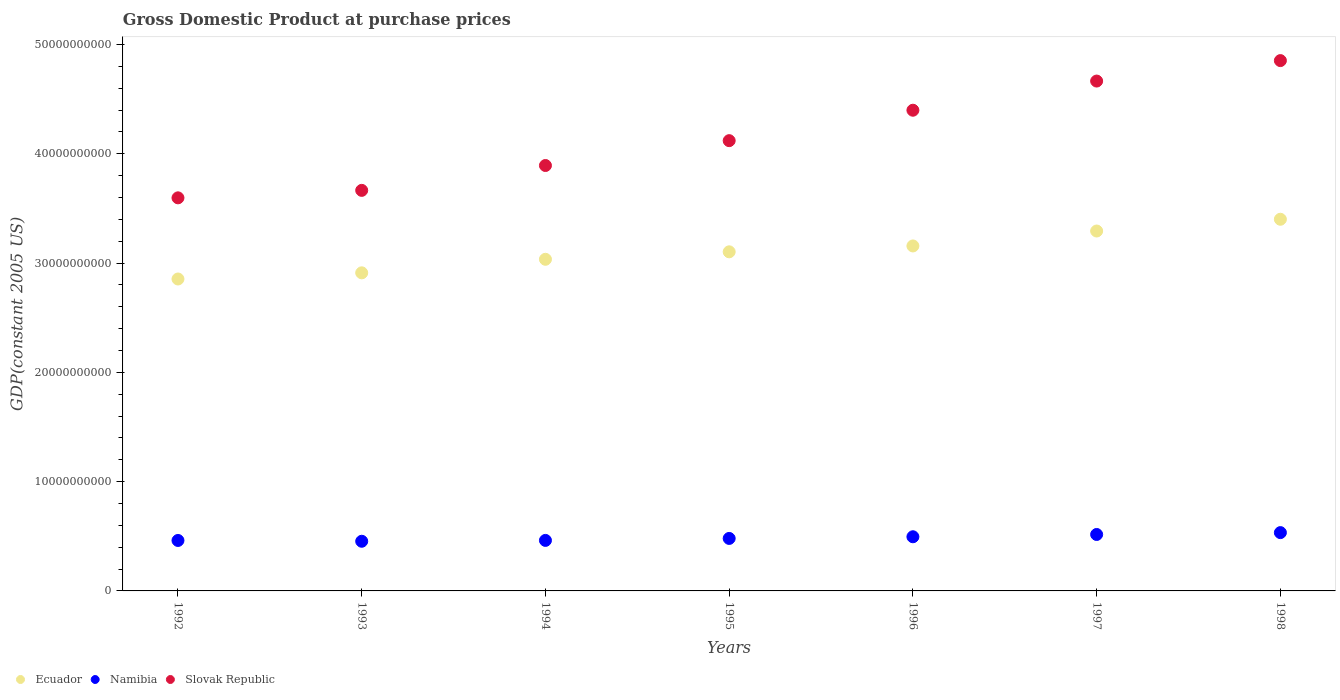How many different coloured dotlines are there?
Give a very brief answer. 3. Is the number of dotlines equal to the number of legend labels?
Provide a succinct answer. Yes. What is the GDP at purchase prices in Ecuador in 1994?
Ensure brevity in your answer.  3.03e+1. Across all years, what is the maximum GDP at purchase prices in Ecuador?
Keep it short and to the point. 3.40e+1. Across all years, what is the minimum GDP at purchase prices in Ecuador?
Offer a terse response. 2.85e+1. What is the total GDP at purchase prices in Slovak Republic in the graph?
Provide a short and direct response. 2.92e+11. What is the difference between the GDP at purchase prices in Ecuador in 1996 and that in 1997?
Ensure brevity in your answer.  -1.37e+09. What is the difference between the GDP at purchase prices in Namibia in 1992 and the GDP at purchase prices in Slovak Republic in 1996?
Your answer should be compact. -3.94e+1. What is the average GDP at purchase prices in Slovak Republic per year?
Keep it short and to the point. 4.17e+1. In the year 1997, what is the difference between the GDP at purchase prices in Namibia and GDP at purchase prices in Slovak Republic?
Keep it short and to the point. -4.15e+1. What is the ratio of the GDP at purchase prices in Slovak Republic in 1992 to that in 1994?
Make the answer very short. 0.92. Is the GDP at purchase prices in Slovak Republic in 1995 less than that in 1996?
Give a very brief answer. Yes. Is the difference between the GDP at purchase prices in Namibia in 1992 and 1997 greater than the difference between the GDP at purchase prices in Slovak Republic in 1992 and 1997?
Your answer should be very brief. Yes. What is the difference between the highest and the second highest GDP at purchase prices in Ecuador?
Provide a succinct answer. 1.08e+09. What is the difference between the highest and the lowest GDP at purchase prices in Slovak Republic?
Keep it short and to the point. 1.26e+1. Is the sum of the GDP at purchase prices in Ecuador in 1992 and 1994 greater than the maximum GDP at purchase prices in Slovak Republic across all years?
Ensure brevity in your answer.  Yes. Is it the case that in every year, the sum of the GDP at purchase prices in Slovak Republic and GDP at purchase prices in Namibia  is greater than the GDP at purchase prices in Ecuador?
Offer a very short reply. Yes. Is the GDP at purchase prices in Slovak Republic strictly greater than the GDP at purchase prices in Namibia over the years?
Your response must be concise. Yes. Are the values on the major ticks of Y-axis written in scientific E-notation?
Offer a very short reply. No. Does the graph contain grids?
Offer a terse response. No. How many legend labels are there?
Give a very brief answer. 3. What is the title of the graph?
Your response must be concise. Gross Domestic Product at purchase prices. What is the label or title of the X-axis?
Your answer should be very brief. Years. What is the label or title of the Y-axis?
Your answer should be very brief. GDP(constant 2005 US). What is the GDP(constant 2005 US) in Ecuador in 1992?
Offer a very short reply. 2.85e+1. What is the GDP(constant 2005 US) of Namibia in 1992?
Provide a succinct answer. 4.62e+09. What is the GDP(constant 2005 US) of Slovak Republic in 1992?
Give a very brief answer. 3.60e+1. What is the GDP(constant 2005 US) of Ecuador in 1993?
Offer a very short reply. 2.91e+1. What is the GDP(constant 2005 US) of Namibia in 1993?
Your response must be concise. 4.54e+09. What is the GDP(constant 2005 US) of Slovak Republic in 1993?
Your response must be concise. 3.67e+1. What is the GDP(constant 2005 US) in Ecuador in 1994?
Provide a short and direct response. 3.03e+1. What is the GDP(constant 2005 US) of Namibia in 1994?
Offer a very short reply. 4.62e+09. What is the GDP(constant 2005 US) in Slovak Republic in 1994?
Offer a terse response. 3.89e+1. What is the GDP(constant 2005 US) of Ecuador in 1995?
Ensure brevity in your answer.  3.10e+1. What is the GDP(constant 2005 US) in Namibia in 1995?
Your answer should be very brief. 4.80e+09. What is the GDP(constant 2005 US) of Slovak Republic in 1995?
Provide a short and direct response. 4.12e+1. What is the GDP(constant 2005 US) in Ecuador in 1996?
Keep it short and to the point. 3.16e+1. What is the GDP(constant 2005 US) in Namibia in 1996?
Provide a short and direct response. 4.96e+09. What is the GDP(constant 2005 US) of Slovak Republic in 1996?
Your response must be concise. 4.40e+1. What is the GDP(constant 2005 US) in Ecuador in 1997?
Your response must be concise. 3.29e+1. What is the GDP(constant 2005 US) in Namibia in 1997?
Your answer should be very brief. 5.17e+09. What is the GDP(constant 2005 US) of Slovak Republic in 1997?
Provide a succinct answer. 4.67e+1. What is the GDP(constant 2005 US) in Ecuador in 1998?
Your answer should be very brief. 3.40e+1. What is the GDP(constant 2005 US) in Namibia in 1998?
Your response must be concise. 5.34e+09. What is the GDP(constant 2005 US) of Slovak Republic in 1998?
Your response must be concise. 4.85e+1. Across all years, what is the maximum GDP(constant 2005 US) in Ecuador?
Give a very brief answer. 3.40e+1. Across all years, what is the maximum GDP(constant 2005 US) in Namibia?
Give a very brief answer. 5.34e+09. Across all years, what is the maximum GDP(constant 2005 US) in Slovak Republic?
Your answer should be compact. 4.85e+1. Across all years, what is the minimum GDP(constant 2005 US) in Ecuador?
Your response must be concise. 2.85e+1. Across all years, what is the minimum GDP(constant 2005 US) in Namibia?
Provide a short and direct response. 4.54e+09. Across all years, what is the minimum GDP(constant 2005 US) in Slovak Republic?
Ensure brevity in your answer.  3.60e+1. What is the total GDP(constant 2005 US) of Ecuador in the graph?
Make the answer very short. 2.18e+11. What is the total GDP(constant 2005 US) of Namibia in the graph?
Your response must be concise. 3.40e+1. What is the total GDP(constant 2005 US) in Slovak Republic in the graph?
Make the answer very short. 2.92e+11. What is the difference between the GDP(constant 2005 US) of Ecuador in 1992 and that in 1993?
Make the answer very short. -5.63e+08. What is the difference between the GDP(constant 2005 US) in Namibia in 1992 and that in 1993?
Offer a very short reply. 7.29e+07. What is the difference between the GDP(constant 2005 US) of Slovak Republic in 1992 and that in 1993?
Provide a short and direct response. -6.84e+08. What is the difference between the GDP(constant 2005 US) of Ecuador in 1992 and that in 1994?
Give a very brief answer. -1.80e+09. What is the difference between the GDP(constant 2005 US) in Namibia in 1992 and that in 1994?
Provide a succinct answer. -5.68e+06. What is the difference between the GDP(constant 2005 US) in Slovak Republic in 1992 and that in 1994?
Your answer should be compact. -2.96e+09. What is the difference between the GDP(constant 2005 US) in Ecuador in 1992 and that in 1995?
Ensure brevity in your answer.  -2.49e+09. What is the difference between the GDP(constant 2005 US) of Namibia in 1992 and that in 1995?
Make the answer very short. -1.86e+08. What is the difference between the GDP(constant 2005 US) in Slovak Republic in 1992 and that in 1995?
Give a very brief answer. -5.23e+09. What is the difference between the GDP(constant 2005 US) of Ecuador in 1992 and that in 1996?
Provide a succinct answer. -3.02e+09. What is the difference between the GDP(constant 2005 US) of Namibia in 1992 and that in 1996?
Provide a succinct answer. -3.39e+08. What is the difference between the GDP(constant 2005 US) of Slovak Republic in 1992 and that in 1996?
Offer a terse response. -8.02e+09. What is the difference between the GDP(constant 2005 US) in Ecuador in 1992 and that in 1997?
Provide a succinct answer. -4.39e+09. What is the difference between the GDP(constant 2005 US) in Namibia in 1992 and that in 1997?
Give a very brief answer. -5.48e+08. What is the difference between the GDP(constant 2005 US) in Slovak Republic in 1992 and that in 1997?
Provide a short and direct response. -1.07e+1. What is the difference between the GDP(constant 2005 US) of Ecuador in 1992 and that in 1998?
Your answer should be compact. -5.47e+09. What is the difference between the GDP(constant 2005 US) of Namibia in 1992 and that in 1998?
Your answer should be very brief. -7.18e+08. What is the difference between the GDP(constant 2005 US) of Slovak Republic in 1992 and that in 1998?
Ensure brevity in your answer.  -1.26e+1. What is the difference between the GDP(constant 2005 US) of Ecuador in 1993 and that in 1994?
Your answer should be compact. -1.24e+09. What is the difference between the GDP(constant 2005 US) in Namibia in 1993 and that in 1994?
Provide a short and direct response. -7.86e+07. What is the difference between the GDP(constant 2005 US) in Slovak Republic in 1993 and that in 1994?
Provide a succinct answer. -2.27e+09. What is the difference between the GDP(constant 2005 US) of Ecuador in 1993 and that in 1995?
Give a very brief answer. -1.92e+09. What is the difference between the GDP(constant 2005 US) of Namibia in 1993 and that in 1995?
Your answer should be very brief. -2.59e+08. What is the difference between the GDP(constant 2005 US) of Slovak Republic in 1993 and that in 1995?
Your answer should be compact. -4.55e+09. What is the difference between the GDP(constant 2005 US) of Ecuador in 1993 and that in 1996?
Your response must be concise. -2.46e+09. What is the difference between the GDP(constant 2005 US) of Namibia in 1993 and that in 1996?
Provide a succinct answer. -4.12e+08. What is the difference between the GDP(constant 2005 US) in Slovak Republic in 1993 and that in 1996?
Offer a terse response. -7.33e+09. What is the difference between the GDP(constant 2005 US) of Ecuador in 1993 and that in 1997?
Keep it short and to the point. -3.83e+09. What is the difference between the GDP(constant 2005 US) of Namibia in 1993 and that in 1997?
Offer a terse response. -6.21e+08. What is the difference between the GDP(constant 2005 US) of Slovak Republic in 1993 and that in 1997?
Your response must be concise. -1.00e+1. What is the difference between the GDP(constant 2005 US) in Ecuador in 1993 and that in 1998?
Offer a terse response. -4.90e+09. What is the difference between the GDP(constant 2005 US) in Namibia in 1993 and that in 1998?
Offer a terse response. -7.91e+08. What is the difference between the GDP(constant 2005 US) in Slovak Republic in 1993 and that in 1998?
Provide a succinct answer. -1.19e+1. What is the difference between the GDP(constant 2005 US) of Ecuador in 1994 and that in 1995?
Ensure brevity in your answer.  -6.84e+08. What is the difference between the GDP(constant 2005 US) in Namibia in 1994 and that in 1995?
Your answer should be compact. -1.80e+08. What is the difference between the GDP(constant 2005 US) in Slovak Republic in 1994 and that in 1995?
Keep it short and to the point. -2.27e+09. What is the difference between the GDP(constant 2005 US) in Ecuador in 1994 and that in 1996?
Offer a very short reply. -1.22e+09. What is the difference between the GDP(constant 2005 US) in Namibia in 1994 and that in 1996?
Offer a terse response. -3.34e+08. What is the difference between the GDP(constant 2005 US) of Slovak Republic in 1994 and that in 1996?
Ensure brevity in your answer.  -5.06e+09. What is the difference between the GDP(constant 2005 US) of Ecuador in 1994 and that in 1997?
Provide a short and direct response. -2.59e+09. What is the difference between the GDP(constant 2005 US) in Namibia in 1994 and that in 1997?
Offer a terse response. -5.43e+08. What is the difference between the GDP(constant 2005 US) of Slovak Republic in 1994 and that in 1997?
Offer a terse response. -7.73e+09. What is the difference between the GDP(constant 2005 US) in Ecuador in 1994 and that in 1998?
Give a very brief answer. -3.66e+09. What is the difference between the GDP(constant 2005 US) of Namibia in 1994 and that in 1998?
Your answer should be compact. -7.13e+08. What is the difference between the GDP(constant 2005 US) of Slovak Republic in 1994 and that in 1998?
Keep it short and to the point. -9.60e+09. What is the difference between the GDP(constant 2005 US) of Ecuador in 1995 and that in 1996?
Provide a succinct answer. -5.37e+08. What is the difference between the GDP(constant 2005 US) of Namibia in 1995 and that in 1996?
Offer a very short reply. -1.53e+08. What is the difference between the GDP(constant 2005 US) in Slovak Republic in 1995 and that in 1996?
Provide a succinct answer. -2.78e+09. What is the difference between the GDP(constant 2005 US) in Ecuador in 1995 and that in 1997?
Your response must be concise. -1.90e+09. What is the difference between the GDP(constant 2005 US) of Namibia in 1995 and that in 1997?
Keep it short and to the point. -3.62e+08. What is the difference between the GDP(constant 2005 US) of Slovak Republic in 1995 and that in 1997?
Provide a succinct answer. -5.45e+09. What is the difference between the GDP(constant 2005 US) of Ecuador in 1995 and that in 1998?
Offer a very short reply. -2.98e+09. What is the difference between the GDP(constant 2005 US) in Namibia in 1995 and that in 1998?
Ensure brevity in your answer.  -5.32e+08. What is the difference between the GDP(constant 2005 US) in Slovak Republic in 1995 and that in 1998?
Your answer should be compact. -7.33e+09. What is the difference between the GDP(constant 2005 US) of Ecuador in 1996 and that in 1997?
Provide a succinct answer. -1.37e+09. What is the difference between the GDP(constant 2005 US) in Namibia in 1996 and that in 1997?
Your answer should be compact. -2.09e+08. What is the difference between the GDP(constant 2005 US) of Slovak Republic in 1996 and that in 1997?
Make the answer very short. -2.67e+09. What is the difference between the GDP(constant 2005 US) in Ecuador in 1996 and that in 1998?
Offer a very short reply. -2.44e+09. What is the difference between the GDP(constant 2005 US) in Namibia in 1996 and that in 1998?
Offer a terse response. -3.79e+08. What is the difference between the GDP(constant 2005 US) of Slovak Republic in 1996 and that in 1998?
Offer a terse response. -4.54e+09. What is the difference between the GDP(constant 2005 US) of Ecuador in 1997 and that in 1998?
Provide a short and direct response. -1.08e+09. What is the difference between the GDP(constant 2005 US) of Namibia in 1997 and that in 1998?
Provide a succinct answer. -1.70e+08. What is the difference between the GDP(constant 2005 US) of Slovak Republic in 1997 and that in 1998?
Make the answer very short. -1.87e+09. What is the difference between the GDP(constant 2005 US) of Ecuador in 1992 and the GDP(constant 2005 US) of Namibia in 1993?
Make the answer very short. 2.40e+1. What is the difference between the GDP(constant 2005 US) of Ecuador in 1992 and the GDP(constant 2005 US) of Slovak Republic in 1993?
Your answer should be very brief. -8.11e+09. What is the difference between the GDP(constant 2005 US) in Namibia in 1992 and the GDP(constant 2005 US) in Slovak Republic in 1993?
Your answer should be very brief. -3.20e+1. What is the difference between the GDP(constant 2005 US) in Ecuador in 1992 and the GDP(constant 2005 US) in Namibia in 1994?
Your answer should be compact. 2.39e+1. What is the difference between the GDP(constant 2005 US) of Ecuador in 1992 and the GDP(constant 2005 US) of Slovak Republic in 1994?
Your response must be concise. -1.04e+1. What is the difference between the GDP(constant 2005 US) in Namibia in 1992 and the GDP(constant 2005 US) in Slovak Republic in 1994?
Offer a very short reply. -3.43e+1. What is the difference between the GDP(constant 2005 US) in Ecuador in 1992 and the GDP(constant 2005 US) in Namibia in 1995?
Ensure brevity in your answer.  2.37e+1. What is the difference between the GDP(constant 2005 US) in Ecuador in 1992 and the GDP(constant 2005 US) in Slovak Republic in 1995?
Provide a succinct answer. -1.27e+1. What is the difference between the GDP(constant 2005 US) of Namibia in 1992 and the GDP(constant 2005 US) of Slovak Republic in 1995?
Offer a terse response. -3.66e+1. What is the difference between the GDP(constant 2005 US) in Ecuador in 1992 and the GDP(constant 2005 US) in Namibia in 1996?
Provide a succinct answer. 2.36e+1. What is the difference between the GDP(constant 2005 US) of Ecuador in 1992 and the GDP(constant 2005 US) of Slovak Republic in 1996?
Ensure brevity in your answer.  -1.54e+1. What is the difference between the GDP(constant 2005 US) in Namibia in 1992 and the GDP(constant 2005 US) in Slovak Republic in 1996?
Provide a short and direct response. -3.94e+1. What is the difference between the GDP(constant 2005 US) of Ecuador in 1992 and the GDP(constant 2005 US) of Namibia in 1997?
Your response must be concise. 2.34e+1. What is the difference between the GDP(constant 2005 US) in Ecuador in 1992 and the GDP(constant 2005 US) in Slovak Republic in 1997?
Provide a succinct answer. -1.81e+1. What is the difference between the GDP(constant 2005 US) in Namibia in 1992 and the GDP(constant 2005 US) in Slovak Republic in 1997?
Your answer should be very brief. -4.20e+1. What is the difference between the GDP(constant 2005 US) in Ecuador in 1992 and the GDP(constant 2005 US) in Namibia in 1998?
Your answer should be compact. 2.32e+1. What is the difference between the GDP(constant 2005 US) in Ecuador in 1992 and the GDP(constant 2005 US) in Slovak Republic in 1998?
Provide a short and direct response. -2.00e+1. What is the difference between the GDP(constant 2005 US) in Namibia in 1992 and the GDP(constant 2005 US) in Slovak Republic in 1998?
Provide a succinct answer. -4.39e+1. What is the difference between the GDP(constant 2005 US) of Ecuador in 1993 and the GDP(constant 2005 US) of Namibia in 1994?
Offer a terse response. 2.45e+1. What is the difference between the GDP(constant 2005 US) in Ecuador in 1993 and the GDP(constant 2005 US) in Slovak Republic in 1994?
Offer a terse response. -9.82e+09. What is the difference between the GDP(constant 2005 US) of Namibia in 1993 and the GDP(constant 2005 US) of Slovak Republic in 1994?
Give a very brief answer. -3.44e+1. What is the difference between the GDP(constant 2005 US) in Ecuador in 1993 and the GDP(constant 2005 US) in Namibia in 1995?
Offer a terse response. 2.43e+1. What is the difference between the GDP(constant 2005 US) of Ecuador in 1993 and the GDP(constant 2005 US) of Slovak Republic in 1995?
Your response must be concise. -1.21e+1. What is the difference between the GDP(constant 2005 US) of Namibia in 1993 and the GDP(constant 2005 US) of Slovak Republic in 1995?
Give a very brief answer. -3.67e+1. What is the difference between the GDP(constant 2005 US) in Ecuador in 1993 and the GDP(constant 2005 US) in Namibia in 1996?
Offer a very short reply. 2.42e+1. What is the difference between the GDP(constant 2005 US) of Ecuador in 1993 and the GDP(constant 2005 US) of Slovak Republic in 1996?
Your answer should be compact. -1.49e+1. What is the difference between the GDP(constant 2005 US) in Namibia in 1993 and the GDP(constant 2005 US) in Slovak Republic in 1996?
Make the answer very short. -3.94e+1. What is the difference between the GDP(constant 2005 US) of Ecuador in 1993 and the GDP(constant 2005 US) of Namibia in 1997?
Give a very brief answer. 2.39e+1. What is the difference between the GDP(constant 2005 US) in Ecuador in 1993 and the GDP(constant 2005 US) in Slovak Republic in 1997?
Ensure brevity in your answer.  -1.75e+1. What is the difference between the GDP(constant 2005 US) in Namibia in 1993 and the GDP(constant 2005 US) in Slovak Republic in 1997?
Your answer should be very brief. -4.21e+1. What is the difference between the GDP(constant 2005 US) of Ecuador in 1993 and the GDP(constant 2005 US) of Namibia in 1998?
Offer a terse response. 2.38e+1. What is the difference between the GDP(constant 2005 US) of Ecuador in 1993 and the GDP(constant 2005 US) of Slovak Republic in 1998?
Give a very brief answer. -1.94e+1. What is the difference between the GDP(constant 2005 US) of Namibia in 1993 and the GDP(constant 2005 US) of Slovak Republic in 1998?
Offer a very short reply. -4.40e+1. What is the difference between the GDP(constant 2005 US) in Ecuador in 1994 and the GDP(constant 2005 US) in Namibia in 1995?
Keep it short and to the point. 2.55e+1. What is the difference between the GDP(constant 2005 US) of Ecuador in 1994 and the GDP(constant 2005 US) of Slovak Republic in 1995?
Offer a terse response. -1.09e+1. What is the difference between the GDP(constant 2005 US) in Namibia in 1994 and the GDP(constant 2005 US) in Slovak Republic in 1995?
Provide a short and direct response. -3.66e+1. What is the difference between the GDP(constant 2005 US) of Ecuador in 1994 and the GDP(constant 2005 US) of Namibia in 1996?
Keep it short and to the point. 2.54e+1. What is the difference between the GDP(constant 2005 US) of Ecuador in 1994 and the GDP(constant 2005 US) of Slovak Republic in 1996?
Give a very brief answer. -1.36e+1. What is the difference between the GDP(constant 2005 US) in Namibia in 1994 and the GDP(constant 2005 US) in Slovak Republic in 1996?
Give a very brief answer. -3.94e+1. What is the difference between the GDP(constant 2005 US) of Ecuador in 1994 and the GDP(constant 2005 US) of Namibia in 1997?
Your response must be concise. 2.52e+1. What is the difference between the GDP(constant 2005 US) in Ecuador in 1994 and the GDP(constant 2005 US) in Slovak Republic in 1997?
Provide a short and direct response. -1.63e+1. What is the difference between the GDP(constant 2005 US) of Namibia in 1994 and the GDP(constant 2005 US) of Slovak Republic in 1997?
Your answer should be compact. -4.20e+1. What is the difference between the GDP(constant 2005 US) of Ecuador in 1994 and the GDP(constant 2005 US) of Namibia in 1998?
Ensure brevity in your answer.  2.50e+1. What is the difference between the GDP(constant 2005 US) of Ecuador in 1994 and the GDP(constant 2005 US) of Slovak Republic in 1998?
Make the answer very short. -1.82e+1. What is the difference between the GDP(constant 2005 US) in Namibia in 1994 and the GDP(constant 2005 US) in Slovak Republic in 1998?
Provide a short and direct response. -4.39e+1. What is the difference between the GDP(constant 2005 US) of Ecuador in 1995 and the GDP(constant 2005 US) of Namibia in 1996?
Ensure brevity in your answer.  2.61e+1. What is the difference between the GDP(constant 2005 US) of Ecuador in 1995 and the GDP(constant 2005 US) of Slovak Republic in 1996?
Your answer should be compact. -1.30e+1. What is the difference between the GDP(constant 2005 US) of Namibia in 1995 and the GDP(constant 2005 US) of Slovak Republic in 1996?
Make the answer very short. -3.92e+1. What is the difference between the GDP(constant 2005 US) in Ecuador in 1995 and the GDP(constant 2005 US) in Namibia in 1997?
Your response must be concise. 2.59e+1. What is the difference between the GDP(constant 2005 US) of Ecuador in 1995 and the GDP(constant 2005 US) of Slovak Republic in 1997?
Ensure brevity in your answer.  -1.56e+1. What is the difference between the GDP(constant 2005 US) in Namibia in 1995 and the GDP(constant 2005 US) in Slovak Republic in 1997?
Make the answer very short. -4.19e+1. What is the difference between the GDP(constant 2005 US) in Ecuador in 1995 and the GDP(constant 2005 US) in Namibia in 1998?
Your response must be concise. 2.57e+1. What is the difference between the GDP(constant 2005 US) in Ecuador in 1995 and the GDP(constant 2005 US) in Slovak Republic in 1998?
Ensure brevity in your answer.  -1.75e+1. What is the difference between the GDP(constant 2005 US) in Namibia in 1995 and the GDP(constant 2005 US) in Slovak Republic in 1998?
Give a very brief answer. -4.37e+1. What is the difference between the GDP(constant 2005 US) in Ecuador in 1996 and the GDP(constant 2005 US) in Namibia in 1997?
Give a very brief answer. 2.64e+1. What is the difference between the GDP(constant 2005 US) of Ecuador in 1996 and the GDP(constant 2005 US) of Slovak Republic in 1997?
Provide a short and direct response. -1.51e+1. What is the difference between the GDP(constant 2005 US) of Namibia in 1996 and the GDP(constant 2005 US) of Slovak Republic in 1997?
Make the answer very short. -4.17e+1. What is the difference between the GDP(constant 2005 US) of Ecuador in 1996 and the GDP(constant 2005 US) of Namibia in 1998?
Ensure brevity in your answer.  2.62e+1. What is the difference between the GDP(constant 2005 US) in Ecuador in 1996 and the GDP(constant 2005 US) in Slovak Republic in 1998?
Offer a terse response. -1.70e+1. What is the difference between the GDP(constant 2005 US) in Namibia in 1996 and the GDP(constant 2005 US) in Slovak Republic in 1998?
Offer a very short reply. -4.36e+1. What is the difference between the GDP(constant 2005 US) of Ecuador in 1997 and the GDP(constant 2005 US) of Namibia in 1998?
Give a very brief answer. 2.76e+1. What is the difference between the GDP(constant 2005 US) in Ecuador in 1997 and the GDP(constant 2005 US) in Slovak Republic in 1998?
Give a very brief answer. -1.56e+1. What is the difference between the GDP(constant 2005 US) in Namibia in 1997 and the GDP(constant 2005 US) in Slovak Republic in 1998?
Your response must be concise. -4.34e+1. What is the average GDP(constant 2005 US) in Ecuador per year?
Ensure brevity in your answer.  3.11e+1. What is the average GDP(constant 2005 US) of Namibia per year?
Offer a very short reply. 4.86e+09. What is the average GDP(constant 2005 US) in Slovak Republic per year?
Offer a terse response. 4.17e+1. In the year 1992, what is the difference between the GDP(constant 2005 US) of Ecuador and GDP(constant 2005 US) of Namibia?
Offer a very short reply. 2.39e+1. In the year 1992, what is the difference between the GDP(constant 2005 US) in Ecuador and GDP(constant 2005 US) in Slovak Republic?
Provide a short and direct response. -7.43e+09. In the year 1992, what is the difference between the GDP(constant 2005 US) of Namibia and GDP(constant 2005 US) of Slovak Republic?
Make the answer very short. -3.14e+1. In the year 1993, what is the difference between the GDP(constant 2005 US) of Ecuador and GDP(constant 2005 US) of Namibia?
Your response must be concise. 2.46e+1. In the year 1993, what is the difference between the GDP(constant 2005 US) in Ecuador and GDP(constant 2005 US) in Slovak Republic?
Keep it short and to the point. -7.55e+09. In the year 1993, what is the difference between the GDP(constant 2005 US) of Namibia and GDP(constant 2005 US) of Slovak Republic?
Provide a succinct answer. -3.21e+1. In the year 1994, what is the difference between the GDP(constant 2005 US) in Ecuador and GDP(constant 2005 US) in Namibia?
Keep it short and to the point. 2.57e+1. In the year 1994, what is the difference between the GDP(constant 2005 US) of Ecuador and GDP(constant 2005 US) of Slovak Republic?
Ensure brevity in your answer.  -8.58e+09. In the year 1994, what is the difference between the GDP(constant 2005 US) of Namibia and GDP(constant 2005 US) of Slovak Republic?
Your response must be concise. -3.43e+1. In the year 1995, what is the difference between the GDP(constant 2005 US) of Ecuador and GDP(constant 2005 US) of Namibia?
Provide a short and direct response. 2.62e+1. In the year 1995, what is the difference between the GDP(constant 2005 US) of Ecuador and GDP(constant 2005 US) of Slovak Republic?
Your response must be concise. -1.02e+1. In the year 1995, what is the difference between the GDP(constant 2005 US) of Namibia and GDP(constant 2005 US) of Slovak Republic?
Offer a very short reply. -3.64e+1. In the year 1996, what is the difference between the GDP(constant 2005 US) in Ecuador and GDP(constant 2005 US) in Namibia?
Provide a succinct answer. 2.66e+1. In the year 1996, what is the difference between the GDP(constant 2005 US) in Ecuador and GDP(constant 2005 US) in Slovak Republic?
Your answer should be very brief. -1.24e+1. In the year 1996, what is the difference between the GDP(constant 2005 US) in Namibia and GDP(constant 2005 US) in Slovak Republic?
Provide a short and direct response. -3.90e+1. In the year 1997, what is the difference between the GDP(constant 2005 US) of Ecuador and GDP(constant 2005 US) of Namibia?
Your answer should be very brief. 2.78e+1. In the year 1997, what is the difference between the GDP(constant 2005 US) of Ecuador and GDP(constant 2005 US) of Slovak Republic?
Provide a succinct answer. -1.37e+1. In the year 1997, what is the difference between the GDP(constant 2005 US) in Namibia and GDP(constant 2005 US) in Slovak Republic?
Make the answer very short. -4.15e+1. In the year 1998, what is the difference between the GDP(constant 2005 US) in Ecuador and GDP(constant 2005 US) in Namibia?
Make the answer very short. 2.87e+1. In the year 1998, what is the difference between the GDP(constant 2005 US) in Ecuador and GDP(constant 2005 US) in Slovak Republic?
Offer a terse response. -1.45e+1. In the year 1998, what is the difference between the GDP(constant 2005 US) of Namibia and GDP(constant 2005 US) of Slovak Republic?
Your answer should be compact. -4.32e+1. What is the ratio of the GDP(constant 2005 US) in Ecuador in 1992 to that in 1993?
Your answer should be very brief. 0.98. What is the ratio of the GDP(constant 2005 US) of Namibia in 1992 to that in 1993?
Make the answer very short. 1.02. What is the ratio of the GDP(constant 2005 US) in Slovak Republic in 1992 to that in 1993?
Ensure brevity in your answer.  0.98. What is the ratio of the GDP(constant 2005 US) in Ecuador in 1992 to that in 1994?
Make the answer very short. 0.94. What is the ratio of the GDP(constant 2005 US) in Namibia in 1992 to that in 1994?
Provide a short and direct response. 1. What is the ratio of the GDP(constant 2005 US) in Slovak Republic in 1992 to that in 1994?
Keep it short and to the point. 0.92. What is the ratio of the GDP(constant 2005 US) of Ecuador in 1992 to that in 1995?
Offer a terse response. 0.92. What is the ratio of the GDP(constant 2005 US) of Namibia in 1992 to that in 1995?
Make the answer very short. 0.96. What is the ratio of the GDP(constant 2005 US) of Slovak Republic in 1992 to that in 1995?
Your answer should be very brief. 0.87. What is the ratio of the GDP(constant 2005 US) of Ecuador in 1992 to that in 1996?
Your response must be concise. 0.9. What is the ratio of the GDP(constant 2005 US) in Namibia in 1992 to that in 1996?
Make the answer very short. 0.93. What is the ratio of the GDP(constant 2005 US) of Slovak Republic in 1992 to that in 1996?
Your answer should be very brief. 0.82. What is the ratio of the GDP(constant 2005 US) in Ecuador in 1992 to that in 1997?
Keep it short and to the point. 0.87. What is the ratio of the GDP(constant 2005 US) of Namibia in 1992 to that in 1997?
Make the answer very short. 0.89. What is the ratio of the GDP(constant 2005 US) in Slovak Republic in 1992 to that in 1997?
Give a very brief answer. 0.77. What is the ratio of the GDP(constant 2005 US) of Ecuador in 1992 to that in 1998?
Give a very brief answer. 0.84. What is the ratio of the GDP(constant 2005 US) of Namibia in 1992 to that in 1998?
Give a very brief answer. 0.87. What is the ratio of the GDP(constant 2005 US) in Slovak Republic in 1992 to that in 1998?
Your response must be concise. 0.74. What is the ratio of the GDP(constant 2005 US) of Ecuador in 1993 to that in 1994?
Give a very brief answer. 0.96. What is the ratio of the GDP(constant 2005 US) of Namibia in 1993 to that in 1994?
Give a very brief answer. 0.98. What is the ratio of the GDP(constant 2005 US) in Slovak Republic in 1993 to that in 1994?
Your response must be concise. 0.94. What is the ratio of the GDP(constant 2005 US) of Ecuador in 1993 to that in 1995?
Make the answer very short. 0.94. What is the ratio of the GDP(constant 2005 US) in Namibia in 1993 to that in 1995?
Make the answer very short. 0.95. What is the ratio of the GDP(constant 2005 US) of Slovak Republic in 1993 to that in 1995?
Keep it short and to the point. 0.89. What is the ratio of the GDP(constant 2005 US) of Ecuador in 1993 to that in 1996?
Provide a short and direct response. 0.92. What is the ratio of the GDP(constant 2005 US) of Namibia in 1993 to that in 1996?
Ensure brevity in your answer.  0.92. What is the ratio of the GDP(constant 2005 US) in Slovak Republic in 1993 to that in 1996?
Your response must be concise. 0.83. What is the ratio of the GDP(constant 2005 US) in Ecuador in 1993 to that in 1997?
Your response must be concise. 0.88. What is the ratio of the GDP(constant 2005 US) of Namibia in 1993 to that in 1997?
Make the answer very short. 0.88. What is the ratio of the GDP(constant 2005 US) in Slovak Republic in 1993 to that in 1997?
Give a very brief answer. 0.79. What is the ratio of the GDP(constant 2005 US) in Ecuador in 1993 to that in 1998?
Your answer should be very brief. 0.86. What is the ratio of the GDP(constant 2005 US) in Namibia in 1993 to that in 1998?
Ensure brevity in your answer.  0.85. What is the ratio of the GDP(constant 2005 US) in Slovak Republic in 1993 to that in 1998?
Offer a very short reply. 0.76. What is the ratio of the GDP(constant 2005 US) in Ecuador in 1994 to that in 1995?
Your response must be concise. 0.98. What is the ratio of the GDP(constant 2005 US) in Namibia in 1994 to that in 1995?
Offer a very short reply. 0.96. What is the ratio of the GDP(constant 2005 US) in Slovak Republic in 1994 to that in 1995?
Give a very brief answer. 0.94. What is the ratio of the GDP(constant 2005 US) of Ecuador in 1994 to that in 1996?
Your response must be concise. 0.96. What is the ratio of the GDP(constant 2005 US) in Namibia in 1994 to that in 1996?
Your answer should be very brief. 0.93. What is the ratio of the GDP(constant 2005 US) in Slovak Republic in 1994 to that in 1996?
Your answer should be very brief. 0.89. What is the ratio of the GDP(constant 2005 US) of Ecuador in 1994 to that in 1997?
Your answer should be compact. 0.92. What is the ratio of the GDP(constant 2005 US) of Namibia in 1994 to that in 1997?
Provide a short and direct response. 0.89. What is the ratio of the GDP(constant 2005 US) of Slovak Republic in 1994 to that in 1997?
Offer a very short reply. 0.83. What is the ratio of the GDP(constant 2005 US) in Ecuador in 1994 to that in 1998?
Provide a short and direct response. 0.89. What is the ratio of the GDP(constant 2005 US) in Namibia in 1994 to that in 1998?
Offer a terse response. 0.87. What is the ratio of the GDP(constant 2005 US) in Slovak Republic in 1994 to that in 1998?
Offer a terse response. 0.8. What is the ratio of the GDP(constant 2005 US) in Namibia in 1995 to that in 1996?
Offer a terse response. 0.97. What is the ratio of the GDP(constant 2005 US) of Slovak Republic in 1995 to that in 1996?
Your answer should be very brief. 0.94. What is the ratio of the GDP(constant 2005 US) in Ecuador in 1995 to that in 1997?
Give a very brief answer. 0.94. What is the ratio of the GDP(constant 2005 US) in Namibia in 1995 to that in 1997?
Provide a succinct answer. 0.93. What is the ratio of the GDP(constant 2005 US) of Slovak Republic in 1995 to that in 1997?
Offer a terse response. 0.88. What is the ratio of the GDP(constant 2005 US) of Ecuador in 1995 to that in 1998?
Provide a succinct answer. 0.91. What is the ratio of the GDP(constant 2005 US) of Namibia in 1995 to that in 1998?
Provide a short and direct response. 0.9. What is the ratio of the GDP(constant 2005 US) in Slovak Republic in 1995 to that in 1998?
Make the answer very short. 0.85. What is the ratio of the GDP(constant 2005 US) in Ecuador in 1996 to that in 1997?
Your answer should be very brief. 0.96. What is the ratio of the GDP(constant 2005 US) in Namibia in 1996 to that in 1997?
Ensure brevity in your answer.  0.96. What is the ratio of the GDP(constant 2005 US) of Slovak Republic in 1996 to that in 1997?
Provide a short and direct response. 0.94. What is the ratio of the GDP(constant 2005 US) in Ecuador in 1996 to that in 1998?
Provide a short and direct response. 0.93. What is the ratio of the GDP(constant 2005 US) of Namibia in 1996 to that in 1998?
Keep it short and to the point. 0.93. What is the ratio of the GDP(constant 2005 US) of Slovak Republic in 1996 to that in 1998?
Offer a terse response. 0.91. What is the ratio of the GDP(constant 2005 US) of Ecuador in 1997 to that in 1998?
Keep it short and to the point. 0.97. What is the ratio of the GDP(constant 2005 US) of Namibia in 1997 to that in 1998?
Ensure brevity in your answer.  0.97. What is the ratio of the GDP(constant 2005 US) of Slovak Republic in 1997 to that in 1998?
Offer a terse response. 0.96. What is the difference between the highest and the second highest GDP(constant 2005 US) of Ecuador?
Give a very brief answer. 1.08e+09. What is the difference between the highest and the second highest GDP(constant 2005 US) in Namibia?
Your answer should be very brief. 1.70e+08. What is the difference between the highest and the second highest GDP(constant 2005 US) in Slovak Republic?
Provide a succinct answer. 1.87e+09. What is the difference between the highest and the lowest GDP(constant 2005 US) of Ecuador?
Provide a succinct answer. 5.47e+09. What is the difference between the highest and the lowest GDP(constant 2005 US) of Namibia?
Provide a short and direct response. 7.91e+08. What is the difference between the highest and the lowest GDP(constant 2005 US) of Slovak Republic?
Offer a very short reply. 1.26e+1. 